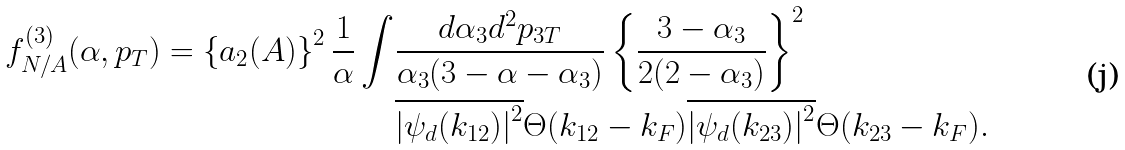<formula> <loc_0><loc_0><loc_500><loc_500>f _ { N / A } ^ { ( 3 ) } ( \alpha , p _ { T } ) = \left \{ a _ { 2 } ( A ) \right \} ^ { 2 } \frac { 1 } { \alpha } \int & \frac { d \alpha _ { 3 } d ^ { 2 } p _ { 3 T } } { \alpha _ { 3 } ( 3 - \alpha - \alpha _ { 3 } ) } \left \{ \frac { 3 - \alpha _ { 3 } } { 2 ( 2 - \alpha _ { 3 } ) } \right \} ^ { 2 } \\ & \overline { \left | { \psi _ { d } ( k _ { 1 2 } ) } \right | ^ { 2 } } \Theta ( k _ { 1 2 } - k _ { F } ) \overline { \left | { \psi _ { d } ( k _ { 2 3 } ) } \right | ^ { 2 } } \Theta ( k _ { 2 3 } - k _ { F } ) .</formula> 